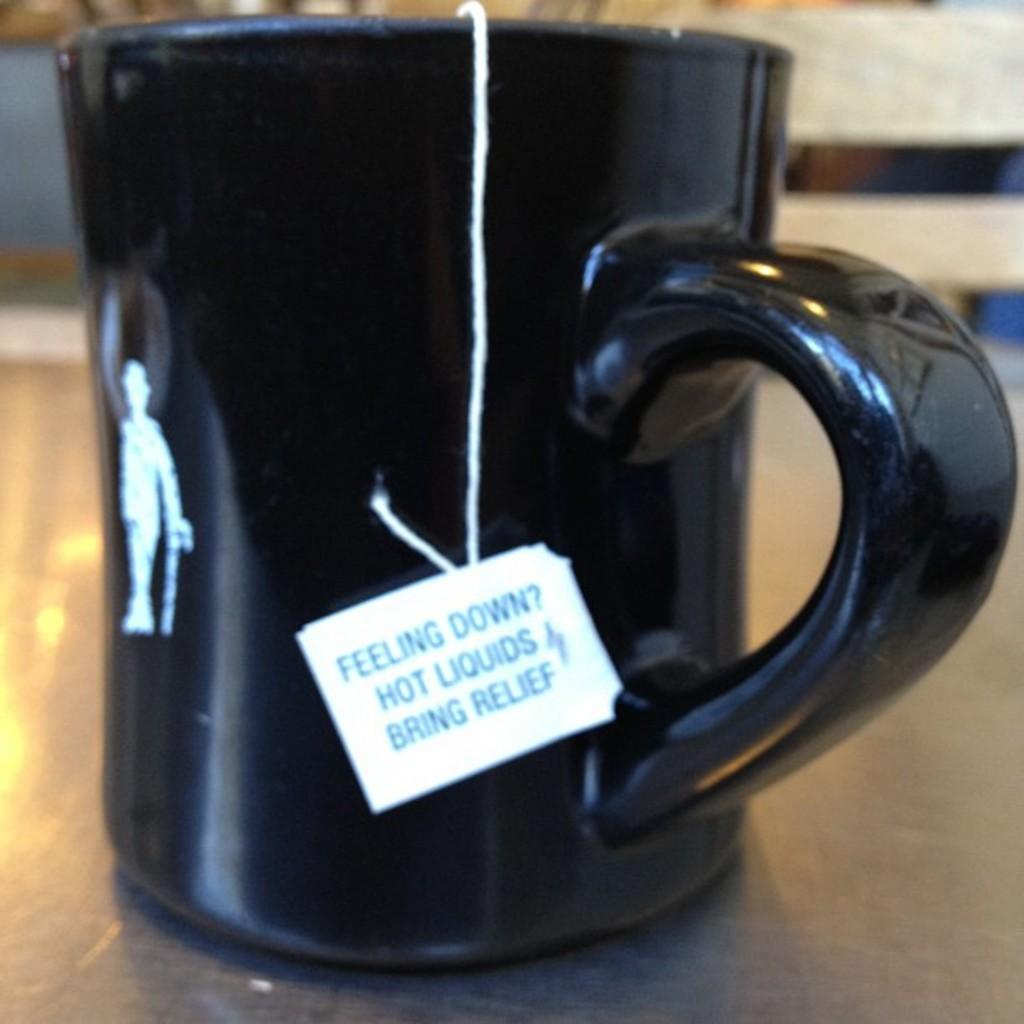What brings relief when you're feeling down?
Provide a succinct answer. Hot liquids. What do hot liquids do?
Provide a short and direct response. Bring relief. 